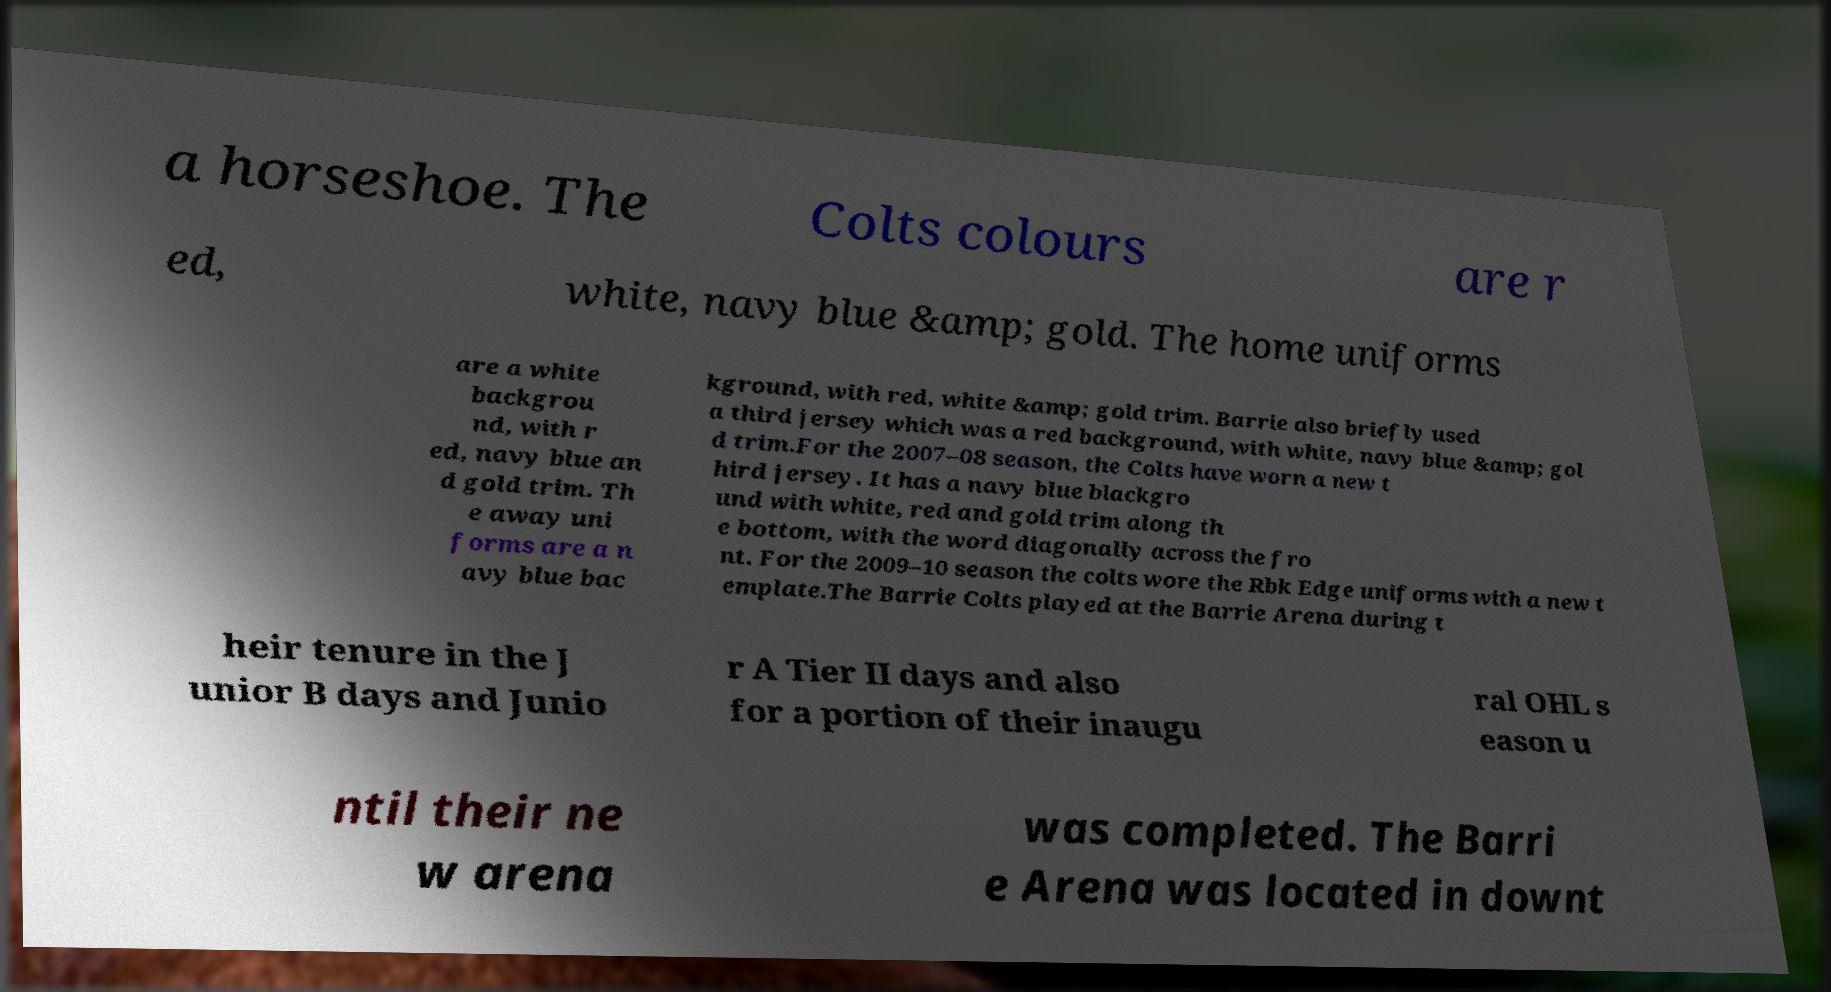Can you read and provide the text displayed in the image?This photo seems to have some interesting text. Can you extract and type it out for me? a horseshoe. The Colts colours are r ed, white, navy blue &amp; gold. The home uniforms are a white backgrou nd, with r ed, navy blue an d gold trim. Th e away uni forms are a n avy blue bac kground, with red, white &amp; gold trim. Barrie also briefly used a third jersey which was a red background, with white, navy blue &amp; gol d trim.For the 2007–08 season, the Colts have worn a new t hird jersey. It has a navy blue blackgro und with white, red and gold trim along th e bottom, with the word diagonally across the fro nt. For the 2009–10 season the colts wore the Rbk Edge uniforms with a new t emplate.The Barrie Colts played at the Barrie Arena during t heir tenure in the J unior B days and Junio r A Tier II days and also for a portion of their inaugu ral OHL s eason u ntil their ne w arena was completed. The Barri e Arena was located in downt 